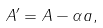<formula> <loc_0><loc_0><loc_500><loc_500>A ^ { \prime } = A - \alpha a ,</formula> 